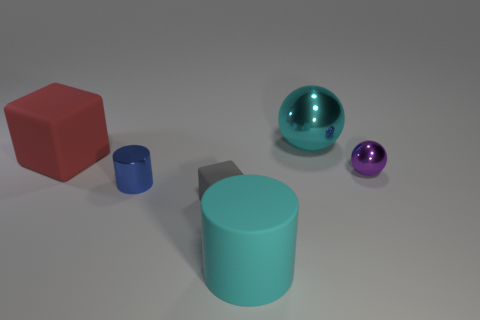There is a big object that is the same color as the big sphere; what material is it?
Offer a terse response. Rubber. The cylinder that is the same color as the big shiny sphere is what size?
Keep it short and to the point. Large. Is the material of the object behind the big red thing the same as the cube in front of the tiny blue object?
Your answer should be compact. No. What shape is the tiny object that is made of the same material as the purple ball?
Ensure brevity in your answer.  Cylinder. Are there any other things that are the same color as the small ball?
Your answer should be compact. No. How many tiny cyan shiny blocks are there?
Make the answer very short. 0. There is a small object that is right of the cube that is in front of the tiny purple shiny thing; what is its material?
Give a very brief answer. Metal. What color is the ball on the left side of the tiny shiny object right of the metal object that is behind the big red matte object?
Provide a short and direct response. Cyan. Do the shiny cylinder and the large matte block have the same color?
Make the answer very short. No. What number of cylinders are the same size as the gray cube?
Your answer should be compact. 1. 